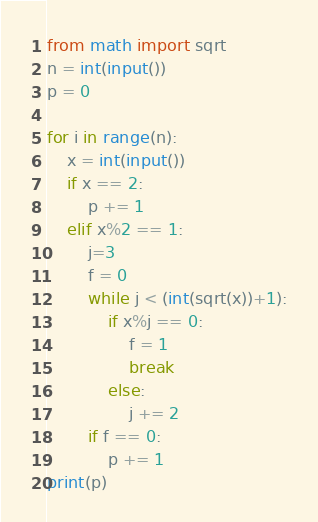<code> <loc_0><loc_0><loc_500><loc_500><_Python_>from math import sqrt
n = int(input())
p = 0

for i in range(n):
    x = int(input())
    if x == 2:
        p += 1
    elif x%2 == 1:
        j=3
        f = 0
        while j < (int(sqrt(x))+1):
            if x%j == 0:
                f = 1
                break
            else:
                j += 2
        if f == 0:
            p += 1
print(p)
</code> 